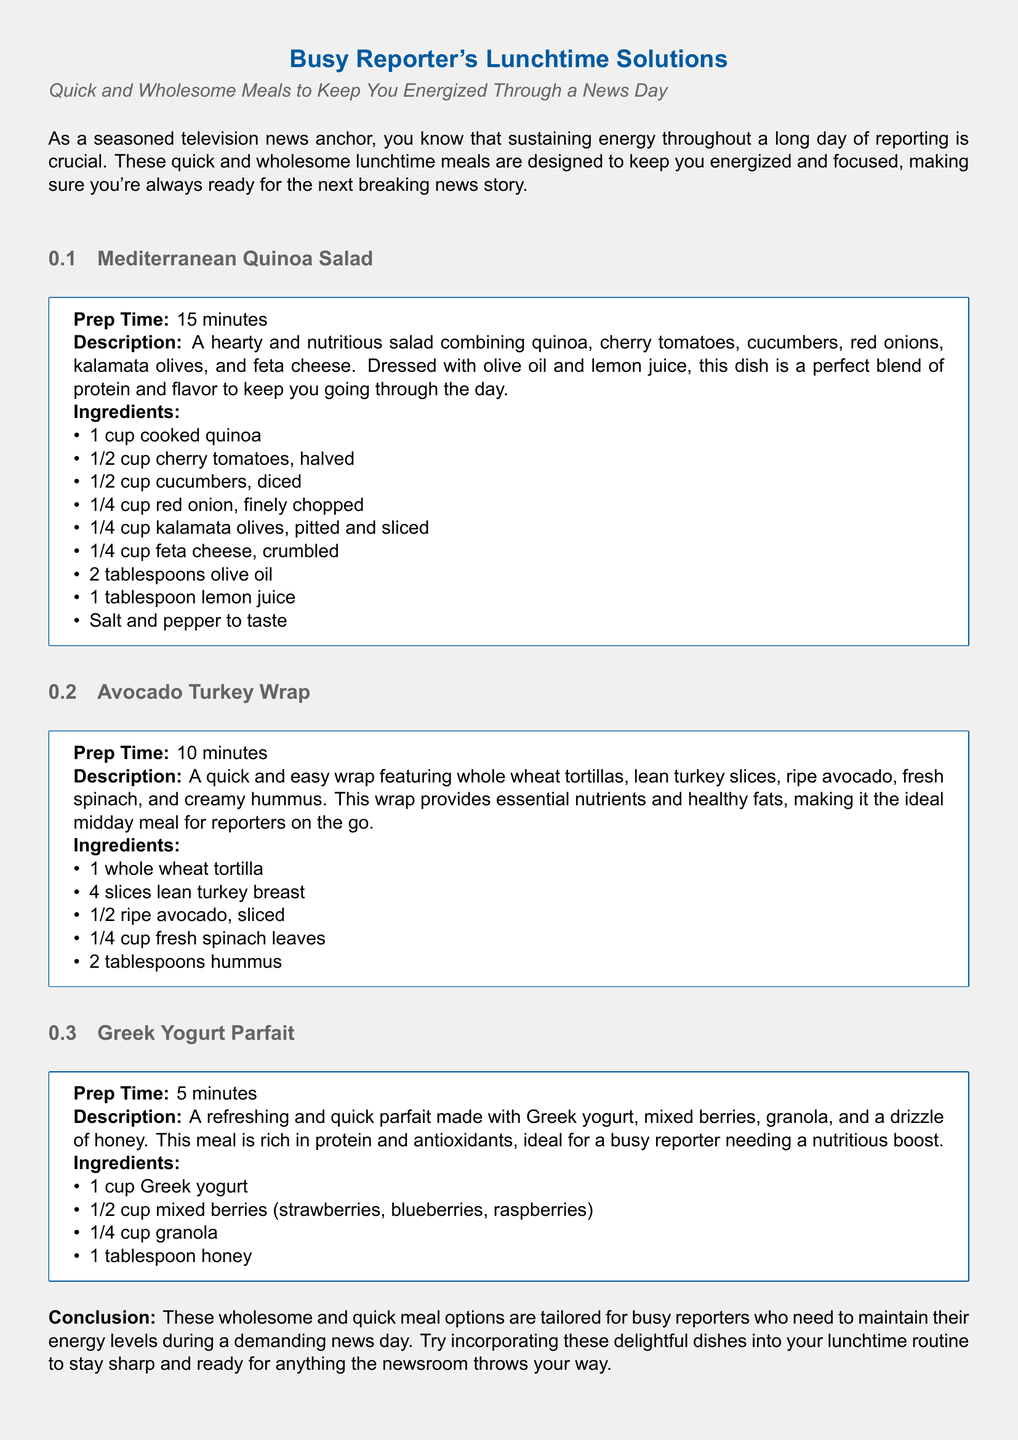What is the first meal listed in the document? The first meal in the document is presented under the section titled "Mediterranean Quinoa Salad."
Answer: Mediterranean Quinoa Salad How long does it take to prepare the Avocado Turkey Wrap? The prep time for the Avocado Turkey Wrap is mentioned as 10 minutes.
Answer: 10 minutes What type of cheese is used in the Mediterranean Quinoa Salad? The cheese used in the Mediterranean Quinoa Salad is feta cheese.
Answer: Feta cheese Which meal requires the least preparation time? The meal that takes the least amount of time to prepare is the Greek Yogurt Parfait, taking only 5 minutes.
Answer: Greek Yogurt Parfait What are the main ingredients in the Avocado Turkey Wrap? The ingredients listed for the Avocado Turkey Wrap include whole wheat tortillas, lean turkey slices, ripe avocado, fresh spinach, and hummus.
Answer: Whole wheat tortillas, lean turkey slices, ripe avocado, fresh spinach, hummus Which meal is described as a "refreshing and quick parfait"? The meal described as a "refreshing and quick parfait" is the Greek Yogurt Parfait.
Answer: Greek Yogurt Parfait What is the primary purpose of the meal suggestions in the document? The primary purpose of the meal suggestions is to provide quick and wholesome meals to keep reporters energized during their workday.
Answer: To keep reporters energized How many tablespoons of olive oil are used in the Mediterranean Quinoa Salad? The Mediterranean Quinoa Salad uses 2 tablespoons of olive oil as per the ingredients listed.
Answer: 2 tablespoons What is the overall theme of the document? The overall theme of the document focuses on providing quick and nutritious meal options for busy reporters.
Answer: Quick and nutritious meal options 